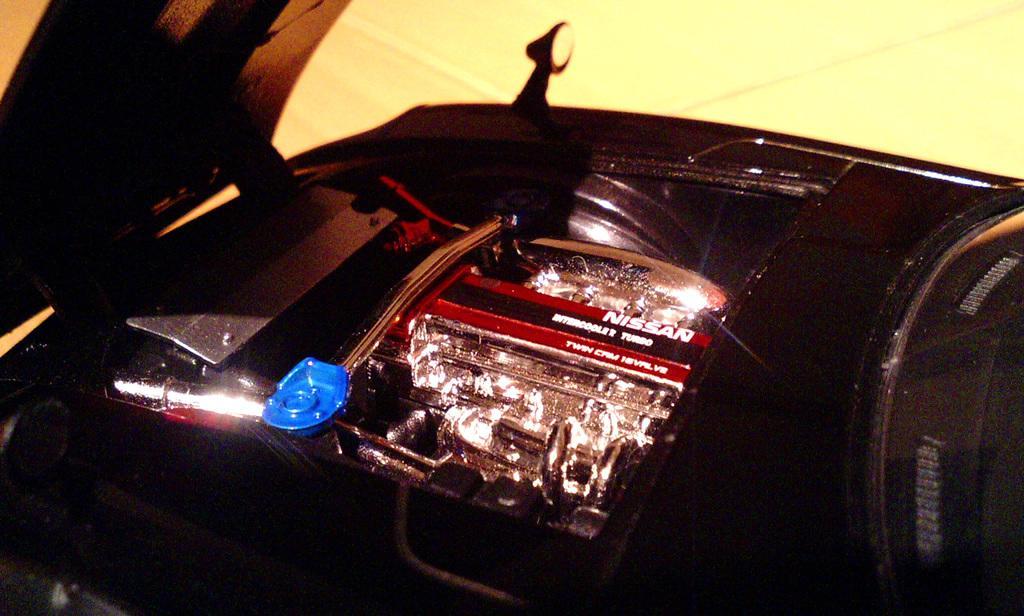Could you give a brief overview of what you see in this image? In this picture I can see the engine part of the car. I can see bonnet on the left side. 